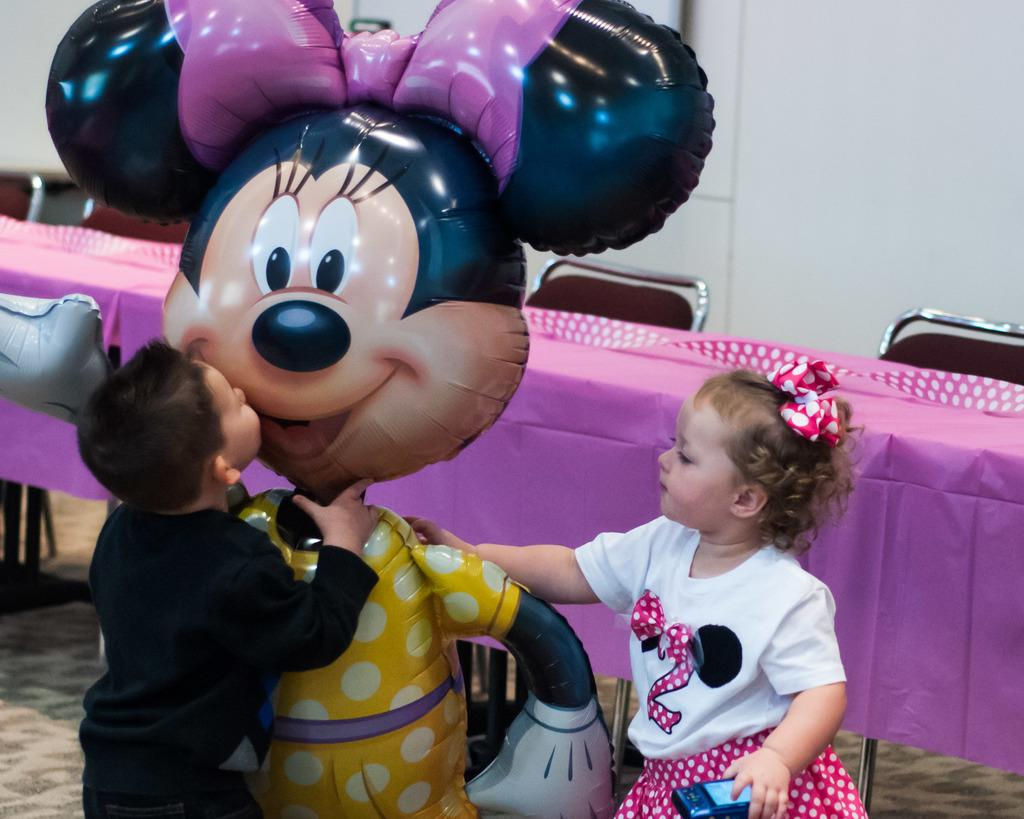How many kids are in the image? There are two kids in the image. What is on the ground near the kids? There is a toy on the ground. What can be seen in the background of the image? There is a platform, chairs, and a wall in the background of the image. What type of alley can be seen behind the wall in the image? There is no alley present in the image; it only shows a wall in the background. 